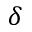<formula> <loc_0><loc_0><loc_500><loc_500>\delta</formula> 